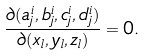<formula> <loc_0><loc_0><loc_500><loc_500>\frac { \partial ( a _ { j } ^ { i } , b _ { j } ^ { i } , c _ { j } ^ { i } , d _ { j } ^ { i } ) } { \partial ( x _ { l } , y _ { l } , z _ { l } ) } = 0 .</formula> 